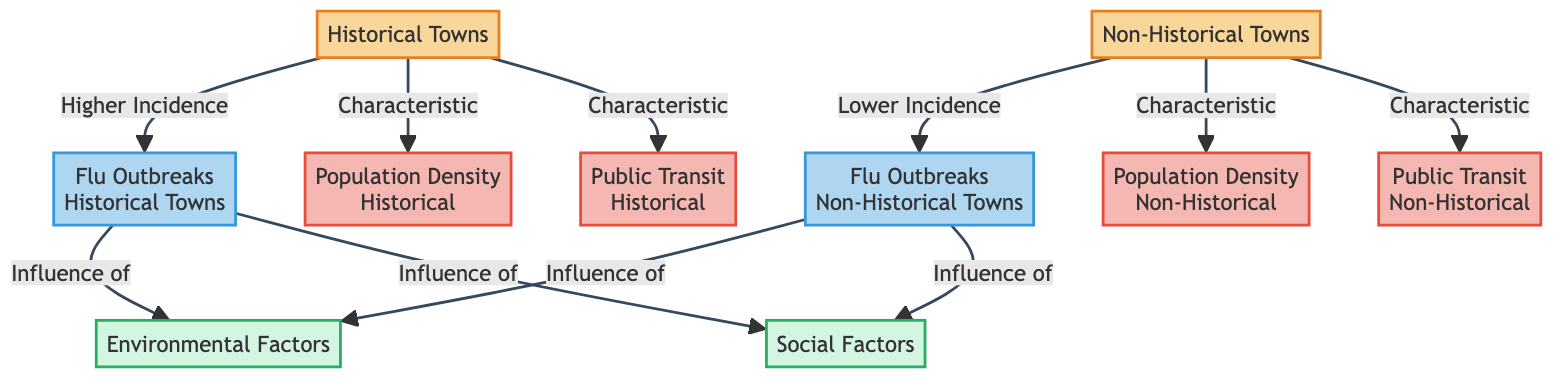What type of towns are indicated in the diagram? The diagram clearly identifies two categories of towns: "Historical Towns" and "Non-Historical Towns," which are the primary nodes of the flowchart.
Answer: Historical and Non-Historical Towns What is the incidence of flu outbreaks in historical towns? According to the diagram, there is a direct connection labeled "Higher Incidence" from "Historical Towns" to "Flu Outbreaks Historical Towns," indicating that these towns experience a higher frequency of flu outbreaks.
Answer: Higher Incidence What factors influence flu outbreaks in both historical and non-historical towns? The diagram shows that both "Flu Outbreaks Historical Towns" and "Flu Outbreaks Non-Historical Towns" are influenced by "Environmental Factors" and "Social Factors," indicating common determinants for both town types.
Answer: Environmental and Social Factors How does the population density compare between historical and non-historical towns? The terms indicated in the diagram reveal that "Population Density Historical" is a characteristic of historical towns, while "Population Density Non-Historical" is a characteristic of non-historical towns, suggesting a distinction in population density between the two categories.
Answer: Distinct Characteristics What is the characteristic of the public transit in historical towns compared to non-historical towns? The diagram illustrates that "Public Transit Historical" is specifically connected to historical towns, while "Public Transit Non-Historical" pertains to non-historical towns. This suggests differing characteristics in public transit history between the two town types.
Answer: Distinct Characteristics What is the relationship between historical towns and flu outbreaks? There is a direct connection in the diagram labeled "Higher Incidence" that links "Historical Towns" to "Flu Outbreaks Historical Towns," indicating a significant relationship implying that historical towns have a higher incidence of flu outbreaks.
Answer: Higher Incidence What is the relationship between non-historical towns and flu outbreaks? The diagram shows a link labeled "Lower Incidence" that connects "Non-Historical Towns" to "Flu Outbreaks Non-Historical Towns," illustrating that non-historical towns experience a lower incidence of flu outbreaks compared to historical towns.
Answer: Lower Incidence How many types of factors influence flu outbreaks in the diagram? The diagram includes two types of factors influencing flu outbreaks, specifically "Environmental Factors" and "Social Factors," which are mentioned in relation to both town categories.
Answer: Two factors 